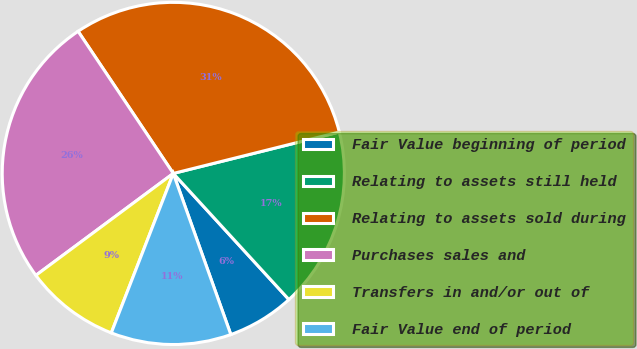Convert chart. <chart><loc_0><loc_0><loc_500><loc_500><pie_chart><fcel>Fair Value beginning of period<fcel>Relating to assets still held<fcel>Relating to assets sold during<fcel>Purchases sales and<fcel>Transfers in and/or out of<fcel>Fair Value end of period<nl><fcel>6.35%<fcel>17.08%<fcel>30.5%<fcel>25.76%<fcel>8.94%<fcel>11.36%<nl></chart> 